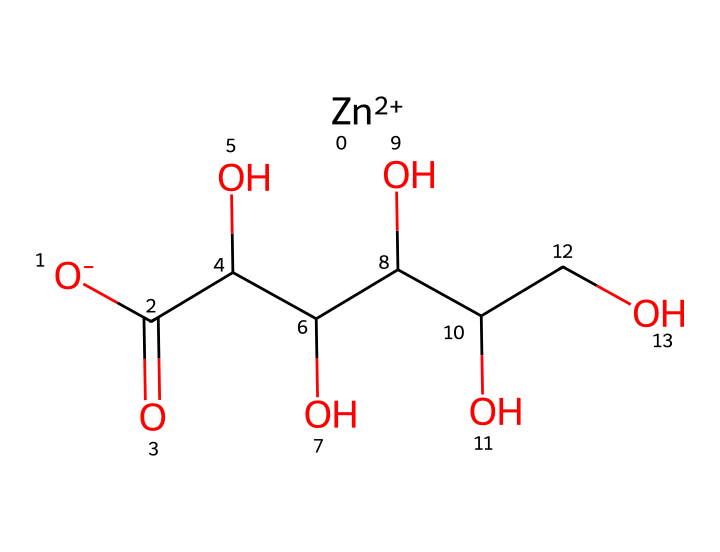What is the chemical formula of zinc gluconate? The chemical is structured with a zinc ion and a gluconate ion. The gluconate ion consists of multiple carbon and oxygen atoms, leading to the formula C12H22O14Zn.
Answer: C12H22O14Zn How many carbon atoms are present in zinc gluconate? By examining the molecular structure from the SMILES notation, there are a total of 6 carbon atoms in the gluconate part of the molecule.
Answer: 6 What type of chemical compound is zinc gluconate primarily classified as? Zinc gluconate is classified as an electrolyte because it dissociates into ions in solution, providing essential minerals.
Answer: electrolyte How many hydroxyl (-OH) groups are in the zinc gluconate structure? By analyzing the structure, there are five hydroxyl (-OH) groups attached to the carbon backbone, indicating its solubility and reactivity in solution.
Answer: 5 What does the presence of zinc in the structure indicate about zinc gluconate's role in dietary supplements? Zinc is a crucial trace element for various biochemical processes, indicating that zinc gluconate serves as a source of zinc in supplements.
Answer: source of zinc What is the role of the carboxyl groups in the gluconate portion of zinc gluconate? The carboxyl groups (-COOH) in the gluconate structure contribute to its acidic properties and aid in solubility and electrolyte balance in the body.
Answer: contribute to acidity 